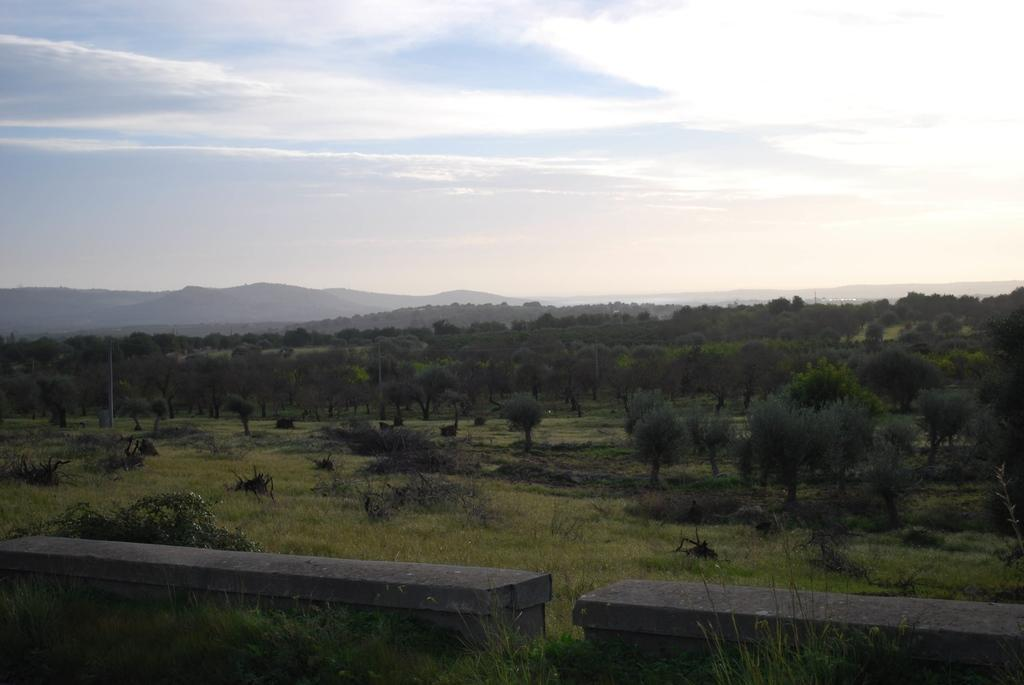What type of natural environment is depicted in the image? There is greenery in the image, suggesting a natural setting. What type of seating is present in the image? There are two cement benches in the front of the image. What can be seen in the distance in the image? There are mountains visible in the background of the image. Where is the note attached to the chain in the image? There is no note or chain present in the image. What type of spot is visible on the mountains in the image? There are no spots visible on the mountains in the image; they appear to be solid and continuous. 